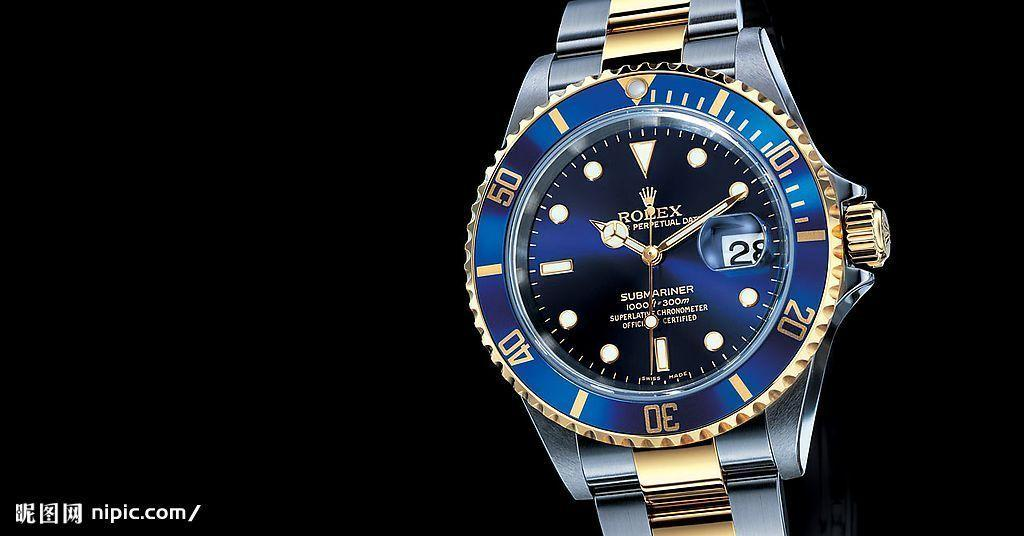<image>
Summarize the visual content of the image. The Rolex Submariner watch is displayed against a black background. 